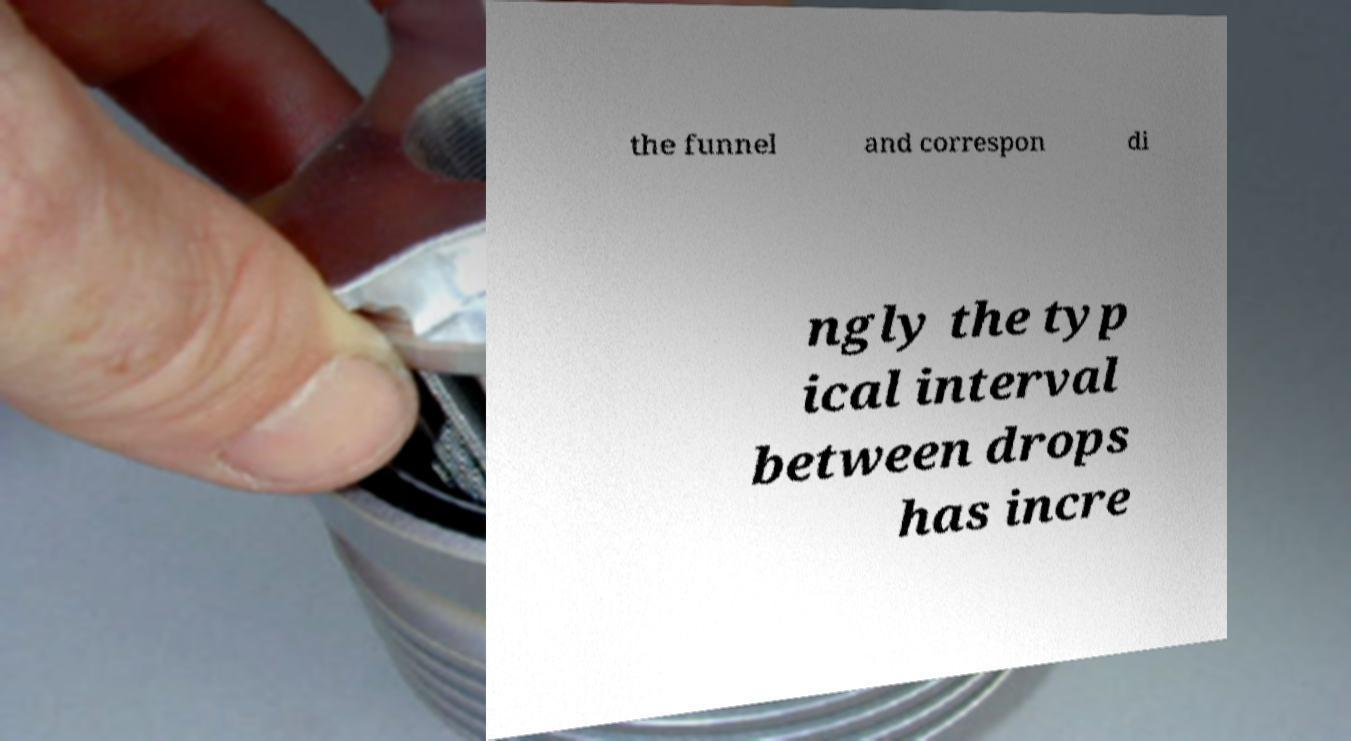Please read and relay the text visible in this image. What does it say? the funnel and correspon di ngly the typ ical interval between drops has incre 